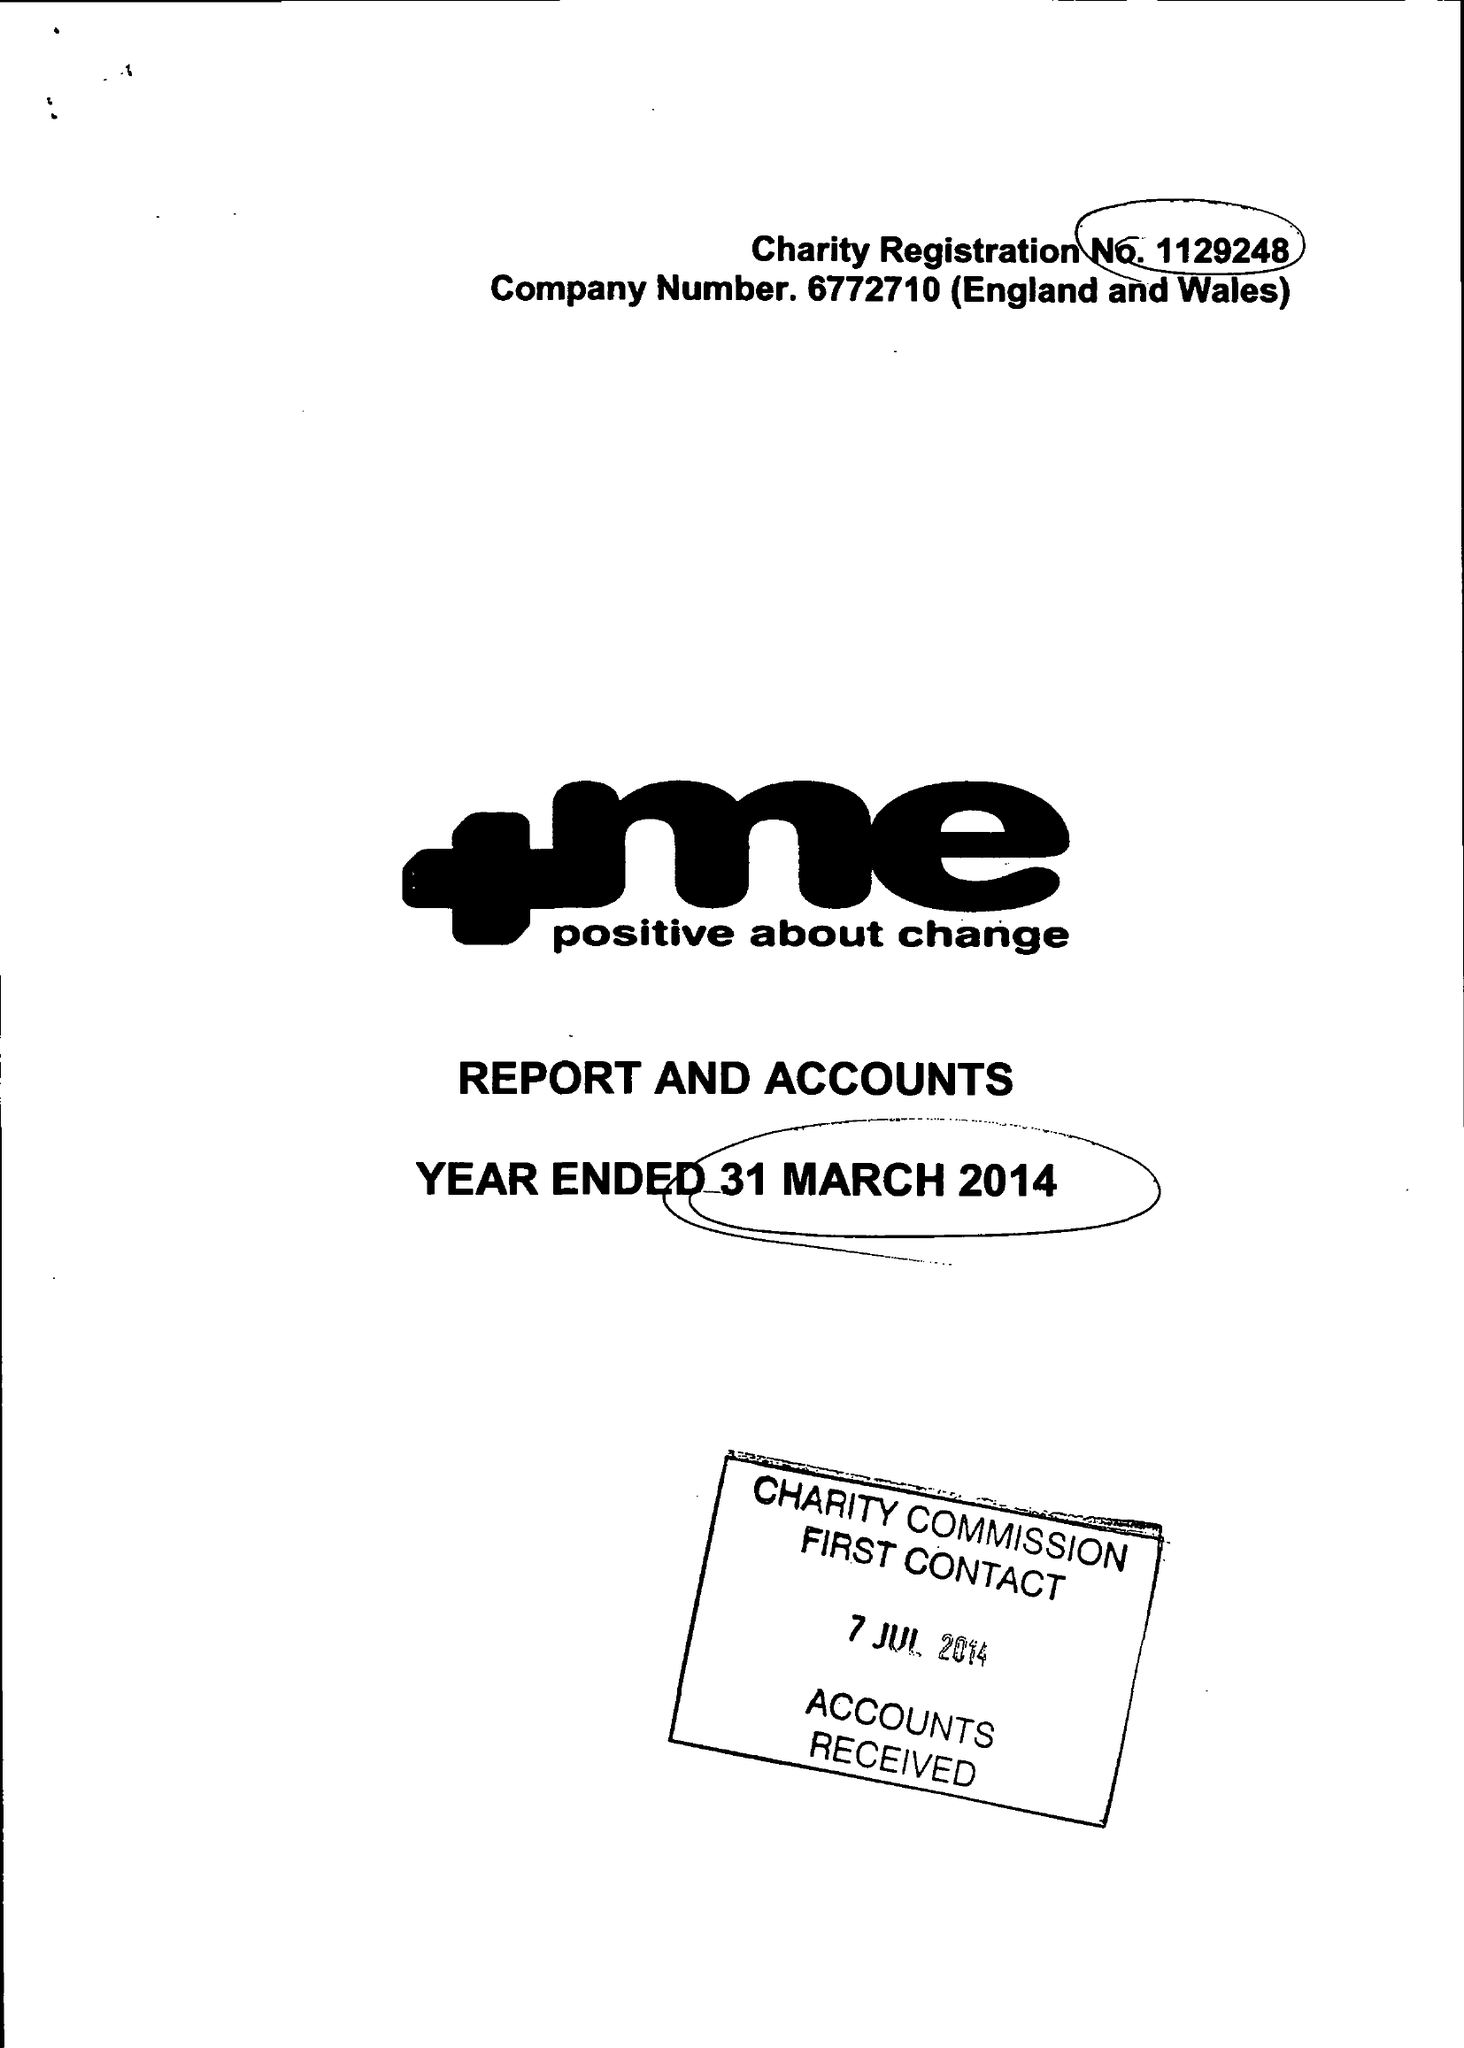What is the value for the charity_number?
Answer the question using a single word or phrase. 1129248 